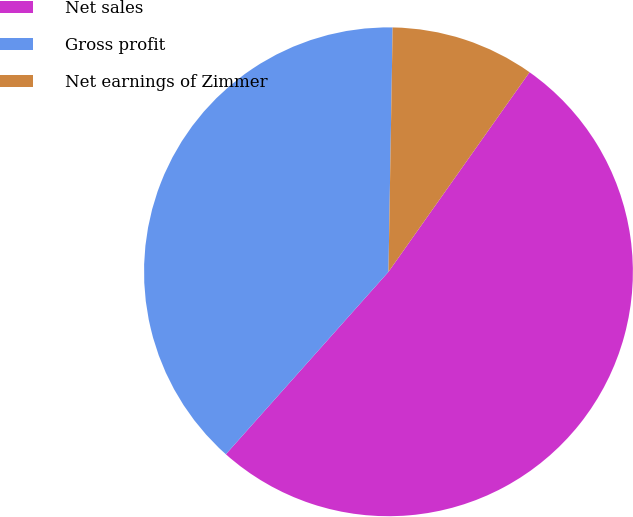<chart> <loc_0><loc_0><loc_500><loc_500><pie_chart><fcel>Net sales<fcel>Gross profit<fcel>Net earnings of Zimmer<nl><fcel>51.8%<fcel>38.69%<fcel>9.52%<nl></chart> 